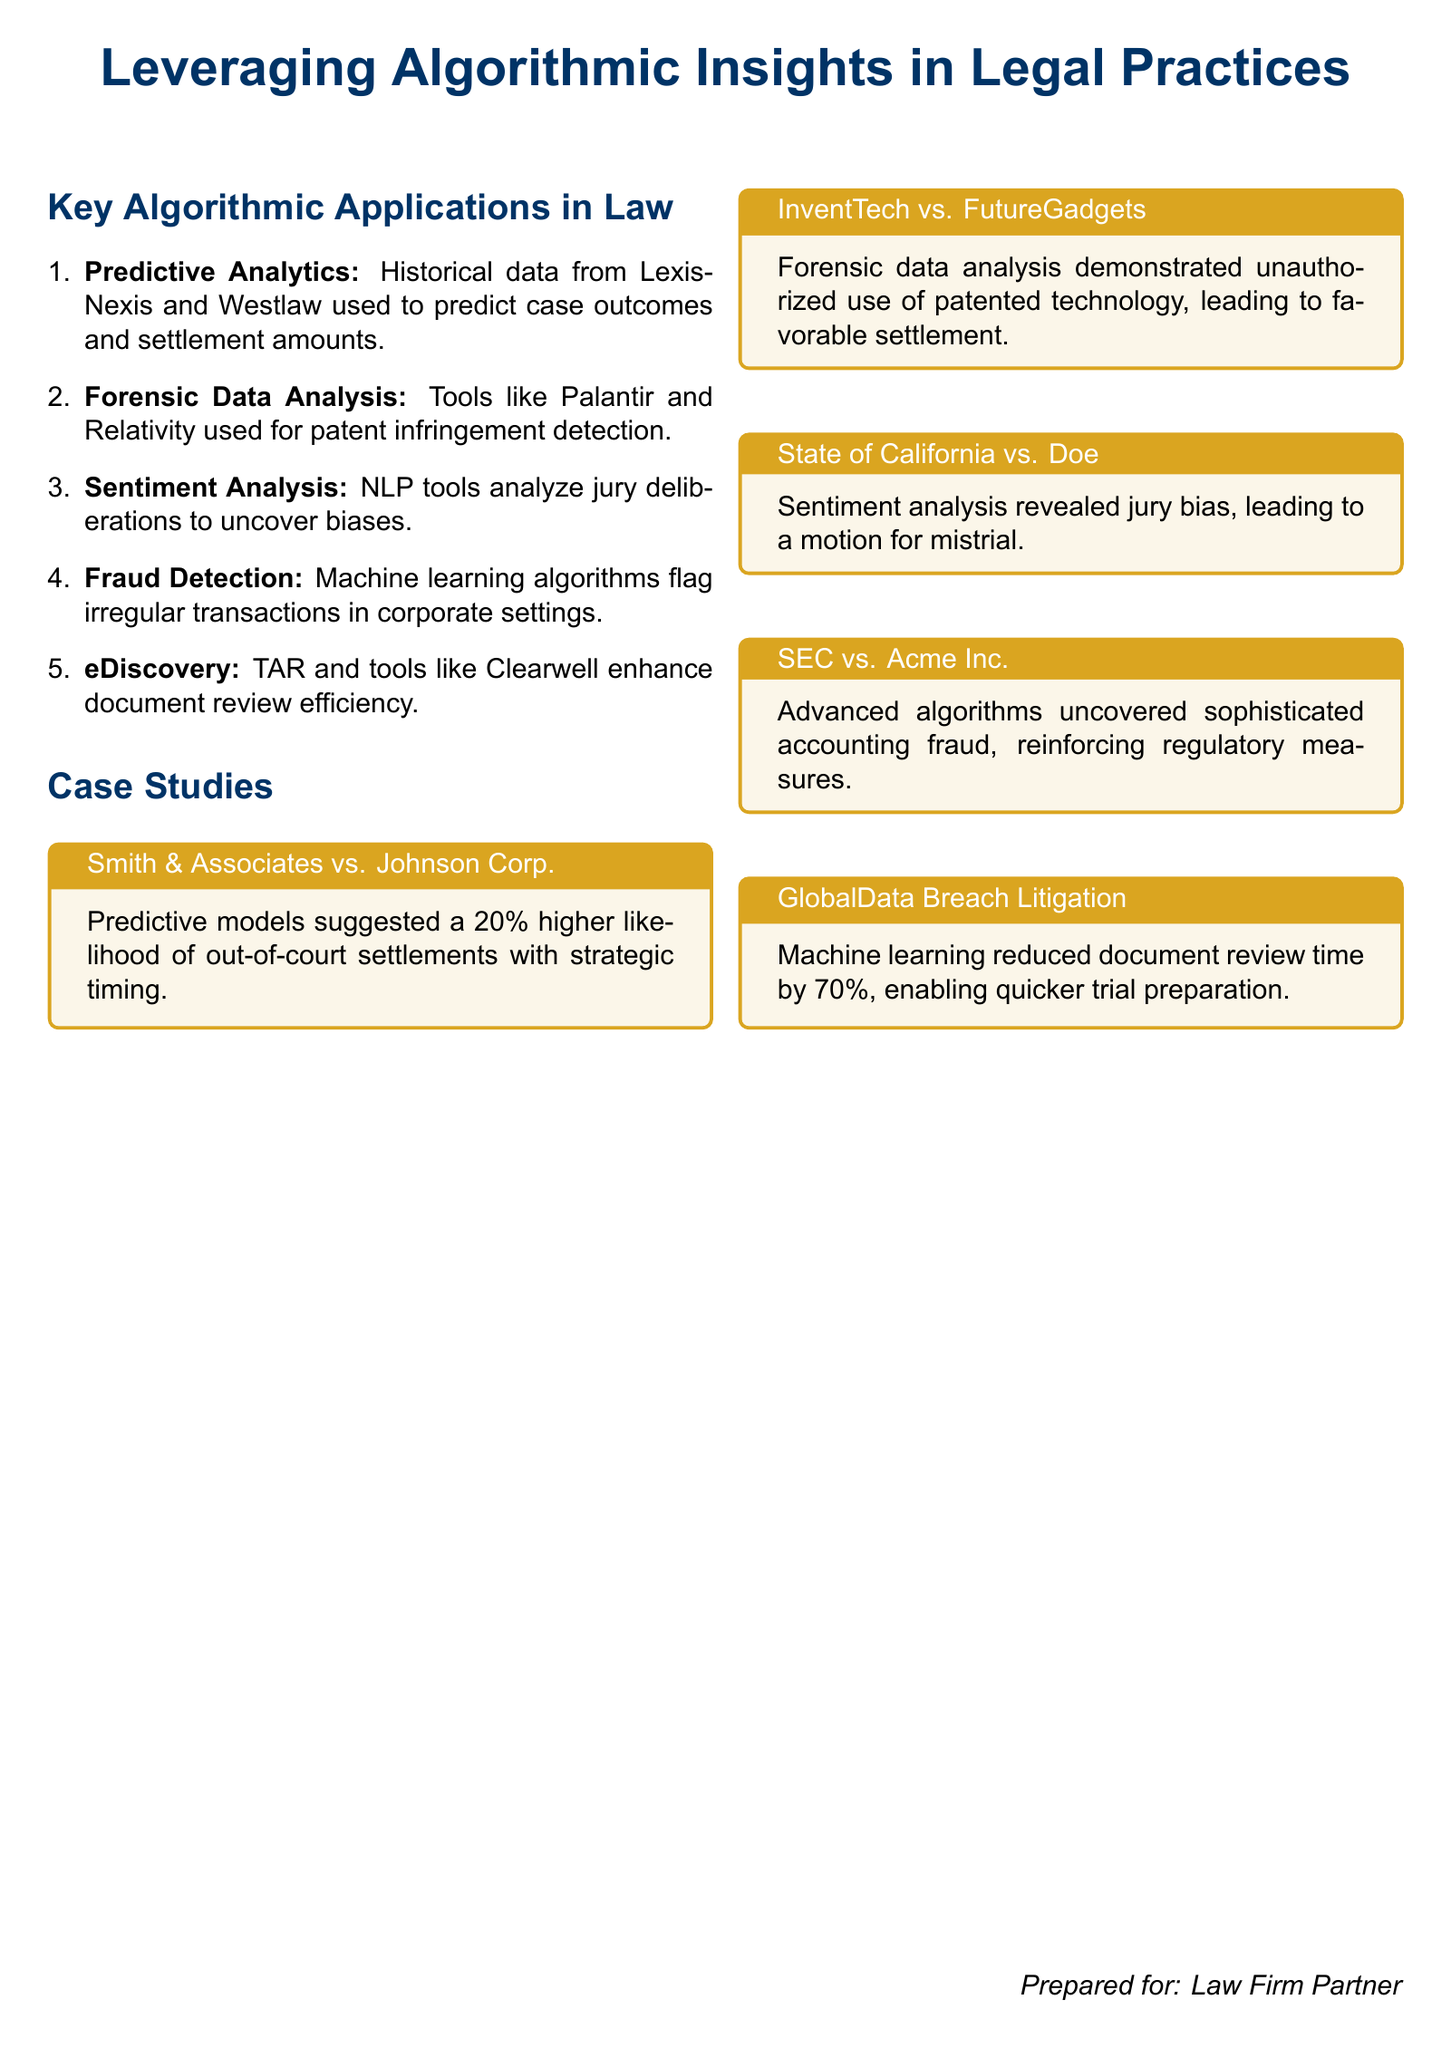What is the main topic of the document? The main topic of the document is leveraging algorithmic insights in legal practices.
Answer: leveraging algorithmic insights in legal practices Which case study involved predictive analytics? The document specifies a case study titled Smith & Associates vs. Johnson Corp. which involved predictive models.
Answer: Smith & Associates vs. Johnson Corp What technology was used for patent infringement detection? The document states that tools like Palantir and Relativity were used for patent infringement detection.
Answer: Palantir and Relativity What percentage reduction in document review time was achieved in the GlobalData Breach Litigation case? The document mentions a 70 percent reduction in document review time.
Answer: 70 percent Which case involved uncovering jury bias? The case of State of California vs. Doe is noted for revealing jury bias.
Answer: State of California vs. Doe Which algorithmic application is related to corporate fraud detection? The document identifies machine learning algorithms as the application related to corporate fraud detection.
Answer: machine learning algorithms What is the outcome of the InventTech vs. FutureGadgets case study? The outcome of the case study was a favorable settlement due to unauthorized use of patented technology.
Answer: favorable settlement What role did sentiment analysis play in legal proceedings? Sentiment analysis revealed jury bias leading to a motion for mistrial.
Answer: revealed jury bias Which case study reinforced regulatory measures against fraud? The SEC vs. Acme Inc. case study is specified to have reinforced regulatory measures against fraud.
Answer: SEC vs. Acme Inc 